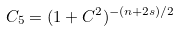Convert formula to latex. <formula><loc_0><loc_0><loc_500><loc_500>C _ { 5 } = ( 1 + C ^ { 2 } ) ^ { - ( n + 2 s ) / 2 }</formula> 